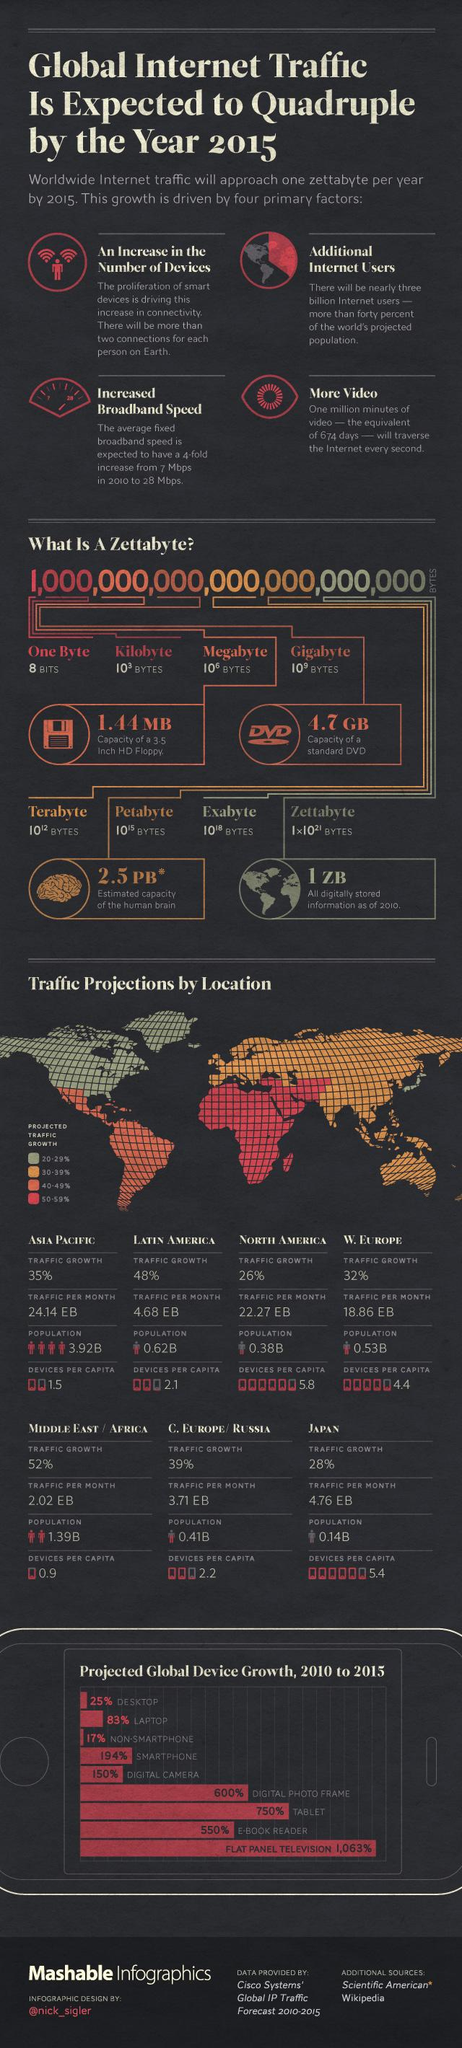List a handful of essential elements in this visual. According to the data provided, the region with the highest traffic growth is the Middle East/Africa. The Middle East/Africa region is projected to experience a traffic growth of 50-59% in the near future. According to the analysis, flat panel televisions are predicted to have the highest growth in the next five years. Digital information has reached a capacity of one zettabyte, which is a unit of measurement representing one sextillion (one followed by 21 zeros) bits of information. The regions with monthly traffic exceeding 20 exabytes are primarily Asia Pacific and North America. 